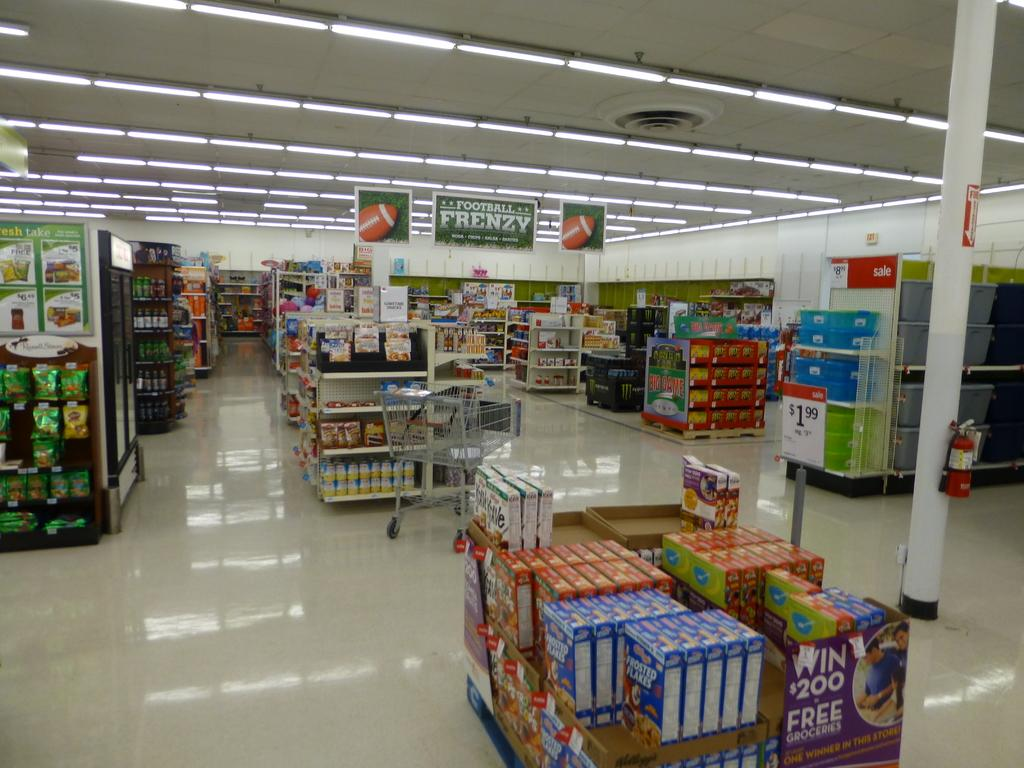<image>
Relay a brief, clear account of the picture shown. Empty store with some Frosted Flakes being sold in front. 